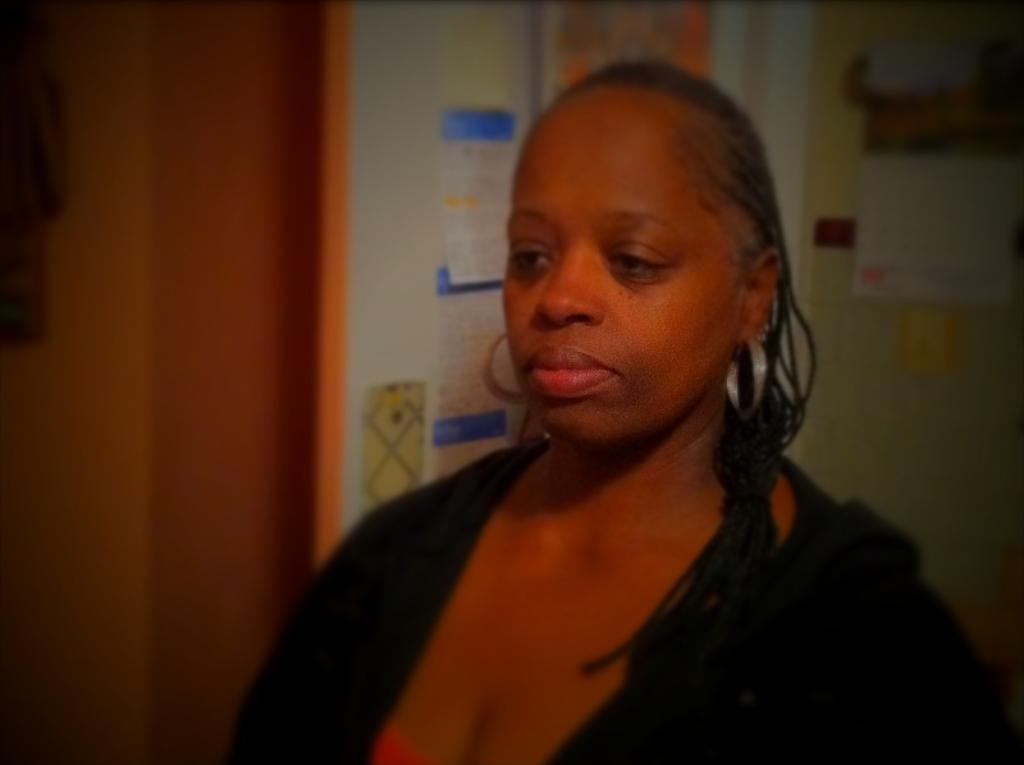Who is present in the image? There is a woman in the image. What can be seen on the wall in the background of the image? There are papers stuck to the wall in the background of the image. How many pets are visible in the image? There are no pets visible in the image. What type of mint is growing in the background of the image? There is no mint present in the image. 